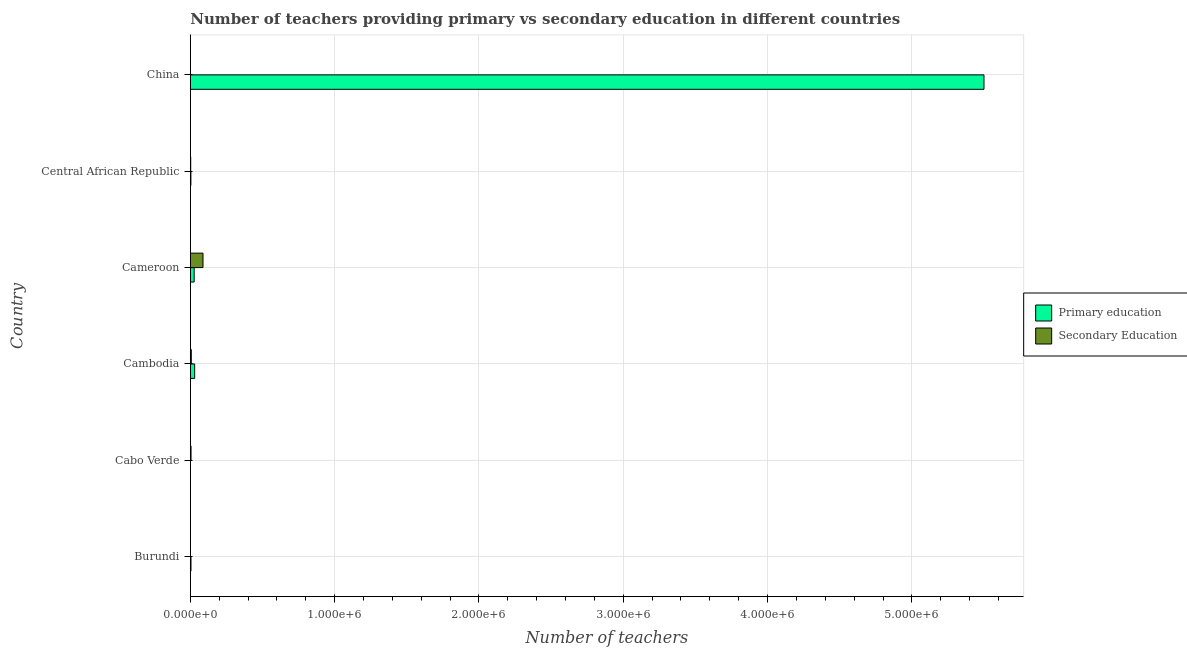Are the number of bars per tick equal to the number of legend labels?
Give a very brief answer. Yes. Are the number of bars on each tick of the Y-axis equal?
Give a very brief answer. Yes. How many bars are there on the 3rd tick from the top?
Make the answer very short. 2. How many bars are there on the 2nd tick from the bottom?
Keep it short and to the point. 2. What is the label of the 3rd group of bars from the top?
Offer a terse response. Cameroon. In how many cases, is the number of bars for a given country not equal to the number of legend labels?
Your answer should be very brief. 0. What is the number of primary teachers in Burundi?
Give a very brief answer. 4805. Across all countries, what is the maximum number of primary teachers?
Your answer should be compact. 5.50e+06. Across all countries, what is the minimum number of secondary teachers?
Provide a short and direct response. 278. In which country was the number of primary teachers minimum?
Make the answer very short. Cabo Verde. What is the total number of primary teachers in the graph?
Make the answer very short. 5.57e+06. What is the difference between the number of secondary teachers in Burundi and that in Central African Republic?
Give a very brief answer. -2504. What is the difference between the number of secondary teachers in China and the number of primary teachers in Cambodia?
Make the answer very short. -3.00e+04. What is the average number of primary teachers per country?
Provide a short and direct response. 9.28e+05. What is the difference between the number of primary teachers and number of secondary teachers in Central African Republic?
Your answer should be compact. 1177. What is the ratio of the number of secondary teachers in Burundi to that in China?
Your answer should be very brief. 1.61. Is the difference between the number of primary teachers in Cabo Verde and Cambodia greater than the difference between the number of secondary teachers in Cabo Verde and Cambodia?
Your response must be concise. No. What is the difference between the highest and the second highest number of primary teachers?
Offer a very short reply. 5.47e+06. What is the difference between the highest and the lowest number of primary teachers?
Provide a short and direct response. 5.50e+06. What does the 2nd bar from the top in Central African Republic represents?
Provide a succinct answer. Primary education. What does the 1st bar from the bottom in Cambodia represents?
Your answer should be very brief. Primary education. Are all the bars in the graph horizontal?
Ensure brevity in your answer.  Yes. Does the graph contain grids?
Provide a short and direct response. Yes. What is the title of the graph?
Keep it short and to the point. Number of teachers providing primary vs secondary education in different countries. What is the label or title of the X-axis?
Keep it short and to the point. Number of teachers. What is the label or title of the Y-axis?
Your response must be concise. Country. What is the Number of teachers in Primary education in Burundi?
Keep it short and to the point. 4805. What is the Number of teachers of Secondary Education in Burundi?
Keep it short and to the point. 449. What is the Number of teachers in Primary education in Cabo Verde?
Provide a succinct answer. 1436. What is the Number of teachers in Secondary Education in Cabo Verde?
Provide a succinct answer. 5117. What is the Number of teachers in Primary education in Cambodia?
Offer a very short reply. 3.03e+04. What is the Number of teachers of Secondary Education in Cambodia?
Provide a short and direct response. 6955. What is the Number of teachers in Primary education in Cameroon?
Your answer should be compact. 2.68e+04. What is the Number of teachers of Secondary Education in Cameroon?
Offer a very short reply. 8.80e+04. What is the Number of teachers of Primary education in Central African Republic?
Your answer should be compact. 4130. What is the Number of teachers of Secondary Education in Central African Republic?
Offer a very short reply. 2953. What is the Number of teachers of Primary education in China?
Ensure brevity in your answer.  5.50e+06. What is the Number of teachers in Secondary Education in China?
Your answer should be very brief. 278. Across all countries, what is the maximum Number of teachers of Primary education?
Keep it short and to the point. 5.50e+06. Across all countries, what is the maximum Number of teachers in Secondary Education?
Provide a short and direct response. 8.80e+04. Across all countries, what is the minimum Number of teachers in Primary education?
Ensure brevity in your answer.  1436. Across all countries, what is the minimum Number of teachers in Secondary Education?
Make the answer very short. 278. What is the total Number of teachers of Primary education in the graph?
Ensure brevity in your answer.  5.57e+06. What is the total Number of teachers in Secondary Education in the graph?
Provide a short and direct response. 1.04e+05. What is the difference between the Number of teachers of Primary education in Burundi and that in Cabo Verde?
Your response must be concise. 3369. What is the difference between the Number of teachers in Secondary Education in Burundi and that in Cabo Verde?
Offer a very short reply. -4668. What is the difference between the Number of teachers in Primary education in Burundi and that in Cambodia?
Offer a terse response. -2.55e+04. What is the difference between the Number of teachers of Secondary Education in Burundi and that in Cambodia?
Provide a short and direct response. -6506. What is the difference between the Number of teachers in Primary education in Burundi and that in Cameroon?
Ensure brevity in your answer.  -2.20e+04. What is the difference between the Number of teachers of Secondary Education in Burundi and that in Cameroon?
Offer a terse response. -8.76e+04. What is the difference between the Number of teachers in Primary education in Burundi and that in Central African Republic?
Ensure brevity in your answer.  675. What is the difference between the Number of teachers of Secondary Education in Burundi and that in Central African Republic?
Offer a very short reply. -2504. What is the difference between the Number of teachers of Primary education in Burundi and that in China?
Your answer should be compact. -5.49e+06. What is the difference between the Number of teachers of Secondary Education in Burundi and that in China?
Your answer should be compact. 171. What is the difference between the Number of teachers in Primary education in Cabo Verde and that in Cambodia?
Make the answer very short. -2.89e+04. What is the difference between the Number of teachers of Secondary Education in Cabo Verde and that in Cambodia?
Your response must be concise. -1838. What is the difference between the Number of teachers in Primary education in Cabo Verde and that in Cameroon?
Your answer should be very brief. -2.53e+04. What is the difference between the Number of teachers in Secondary Education in Cabo Verde and that in Cameroon?
Your answer should be very brief. -8.29e+04. What is the difference between the Number of teachers in Primary education in Cabo Verde and that in Central African Republic?
Keep it short and to the point. -2694. What is the difference between the Number of teachers in Secondary Education in Cabo Verde and that in Central African Republic?
Provide a succinct answer. 2164. What is the difference between the Number of teachers of Primary education in Cabo Verde and that in China?
Offer a terse response. -5.50e+06. What is the difference between the Number of teachers in Secondary Education in Cabo Verde and that in China?
Your answer should be very brief. 4839. What is the difference between the Number of teachers in Primary education in Cambodia and that in Cameroon?
Give a very brief answer. 3553. What is the difference between the Number of teachers of Secondary Education in Cambodia and that in Cameroon?
Keep it short and to the point. -8.11e+04. What is the difference between the Number of teachers in Primary education in Cambodia and that in Central African Republic?
Your answer should be compact. 2.62e+04. What is the difference between the Number of teachers in Secondary Education in Cambodia and that in Central African Republic?
Your answer should be very brief. 4002. What is the difference between the Number of teachers in Primary education in Cambodia and that in China?
Give a very brief answer. -5.47e+06. What is the difference between the Number of teachers of Secondary Education in Cambodia and that in China?
Keep it short and to the point. 6677. What is the difference between the Number of teachers of Primary education in Cameroon and that in Central African Republic?
Provide a short and direct response. 2.26e+04. What is the difference between the Number of teachers in Secondary Education in Cameroon and that in Central African Republic?
Offer a terse response. 8.51e+04. What is the difference between the Number of teachers of Primary education in Cameroon and that in China?
Provide a short and direct response. -5.47e+06. What is the difference between the Number of teachers in Secondary Education in Cameroon and that in China?
Your response must be concise. 8.77e+04. What is the difference between the Number of teachers of Primary education in Central African Republic and that in China?
Your answer should be compact. -5.50e+06. What is the difference between the Number of teachers of Secondary Education in Central African Republic and that in China?
Ensure brevity in your answer.  2675. What is the difference between the Number of teachers of Primary education in Burundi and the Number of teachers of Secondary Education in Cabo Verde?
Your answer should be very brief. -312. What is the difference between the Number of teachers of Primary education in Burundi and the Number of teachers of Secondary Education in Cambodia?
Your answer should be very brief. -2150. What is the difference between the Number of teachers of Primary education in Burundi and the Number of teachers of Secondary Education in Cameroon?
Your answer should be compact. -8.32e+04. What is the difference between the Number of teachers in Primary education in Burundi and the Number of teachers in Secondary Education in Central African Republic?
Your answer should be compact. 1852. What is the difference between the Number of teachers of Primary education in Burundi and the Number of teachers of Secondary Education in China?
Keep it short and to the point. 4527. What is the difference between the Number of teachers of Primary education in Cabo Verde and the Number of teachers of Secondary Education in Cambodia?
Provide a short and direct response. -5519. What is the difference between the Number of teachers in Primary education in Cabo Verde and the Number of teachers in Secondary Education in Cameroon?
Make the answer very short. -8.66e+04. What is the difference between the Number of teachers in Primary education in Cabo Verde and the Number of teachers in Secondary Education in Central African Republic?
Make the answer very short. -1517. What is the difference between the Number of teachers in Primary education in Cabo Verde and the Number of teachers in Secondary Education in China?
Make the answer very short. 1158. What is the difference between the Number of teachers of Primary education in Cambodia and the Number of teachers of Secondary Education in Cameroon?
Offer a terse response. -5.77e+04. What is the difference between the Number of teachers in Primary education in Cambodia and the Number of teachers in Secondary Education in Central African Republic?
Give a very brief answer. 2.74e+04. What is the difference between the Number of teachers in Primary education in Cambodia and the Number of teachers in Secondary Education in China?
Give a very brief answer. 3.00e+04. What is the difference between the Number of teachers of Primary education in Cameroon and the Number of teachers of Secondary Education in Central African Republic?
Provide a short and direct response. 2.38e+04. What is the difference between the Number of teachers of Primary education in Cameroon and the Number of teachers of Secondary Education in China?
Ensure brevity in your answer.  2.65e+04. What is the difference between the Number of teachers in Primary education in Central African Republic and the Number of teachers in Secondary Education in China?
Offer a very short reply. 3852. What is the average Number of teachers in Primary education per country?
Provide a short and direct response. 9.28e+05. What is the average Number of teachers of Secondary Education per country?
Ensure brevity in your answer.  1.73e+04. What is the difference between the Number of teachers of Primary education and Number of teachers of Secondary Education in Burundi?
Offer a very short reply. 4356. What is the difference between the Number of teachers of Primary education and Number of teachers of Secondary Education in Cabo Verde?
Make the answer very short. -3681. What is the difference between the Number of teachers in Primary education and Number of teachers in Secondary Education in Cambodia?
Keep it short and to the point. 2.34e+04. What is the difference between the Number of teachers in Primary education and Number of teachers in Secondary Education in Cameroon?
Offer a very short reply. -6.13e+04. What is the difference between the Number of teachers of Primary education and Number of teachers of Secondary Education in Central African Republic?
Make the answer very short. 1177. What is the difference between the Number of teachers of Primary education and Number of teachers of Secondary Education in China?
Your answer should be compact. 5.50e+06. What is the ratio of the Number of teachers of Primary education in Burundi to that in Cabo Verde?
Offer a terse response. 3.35. What is the ratio of the Number of teachers in Secondary Education in Burundi to that in Cabo Verde?
Offer a terse response. 0.09. What is the ratio of the Number of teachers of Primary education in Burundi to that in Cambodia?
Keep it short and to the point. 0.16. What is the ratio of the Number of teachers in Secondary Education in Burundi to that in Cambodia?
Offer a terse response. 0.06. What is the ratio of the Number of teachers of Primary education in Burundi to that in Cameroon?
Your response must be concise. 0.18. What is the ratio of the Number of teachers in Secondary Education in Burundi to that in Cameroon?
Provide a short and direct response. 0.01. What is the ratio of the Number of teachers in Primary education in Burundi to that in Central African Republic?
Your response must be concise. 1.16. What is the ratio of the Number of teachers of Secondary Education in Burundi to that in Central African Republic?
Your response must be concise. 0.15. What is the ratio of the Number of teachers of Primary education in Burundi to that in China?
Your answer should be very brief. 0. What is the ratio of the Number of teachers of Secondary Education in Burundi to that in China?
Offer a terse response. 1.62. What is the ratio of the Number of teachers in Primary education in Cabo Verde to that in Cambodia?
Offer a terse response. 0.05. What is the ratio of the Number of teachers of Secondary Education in Cabo Verde to that in Cambodia?
Provide a short and direct response. 0.74. What is the ratio of the Number of teachers of Primary education in Cabo Verde to that in Cameroon?
Your answer should be compact. 0.05. What is the ratio of the Number of teachers in Secondary Education in Cabo Verde to that in Cameroon?
Give a very brief answer. 0.06. What is the ratio of the Number of teachers in Primary education in Cabo Verde to that in Central African Republic?
Offer a terse response. 0.35. What is the ratio of the Number of teachers in Secondary Education in Cabo Verde to that in Central African Republic?
Make the answer very short. 1.73. What is the ratio of the Number of teachers in Secondary Education in Cabo Verde to that in China?
Give a very brief answer. 18.41. What is the ratio of the Number of teachers of Primary education in Cambodia to that in Cameroon?
Offer a terse response. 1.13. What is the ratio of the Number of teachers of Secondary Education in Cambodia to that in Cameroon?
Ensure brevity in your answer.  0.08. What is the ratio of the Number of teachers in Primary education in Cambodia to that in Central African Republic?
Ensure brevity in your answer.  7.34. What is the ratio of the Number of teachers in Secondary Education in Cambodia to that in Central African Republic?
Your answer should be compact. 2.36. What is the ratio of the Number of teachers of Primary education in Cambodia to that in China?
Keep it short and to the point. 0.01. What is the ratio of the Number of teachers in Secondary Education in Cambodia to that in China?
Make the answer very short. 25.02. What is the ratio of the Number of teachers in Primary education in Cameroon to that in Central African Republic?
Provide a short and direct response. 6.48. What is the ratio of the Number of teachers in Secondary Education in Cameroon to that in Central African Republic?
Your response must be concise. 29.81. What is the ratio of the Number of teachers of Primary education in Cameroon to that in China?
Offer a terse response. 0. What is the ratio of the Number of teachers in Secondary Education in Cameroon to that in China?
Offer a very short reply. 316.61. What is the ratio of the Number of teachers in Primary education in Central African Republic to that in China?
Offer a very short reply. 0. What is the ratio of the Number of teachers of Secondary Education in Central African Republic to that in China?
Your answer should be very brief. 10.62. What is the difference between the highest and the second highest Number of teachers of Primary education?
Provide a succinct answer. 5.47e+06. What is the difference between the highest and the second highest Number of teachers in Secondary Education?
Provide a succinct answer. 8.11e+04. What is the difference between the highest and the lowest Number of teachers of Primary education?
Make the answer very short. 5.50e+06. What is the difference between the highest and the lowest Number of teachers in Secondary Education?
Your response must be concise. 8.77e+04. 